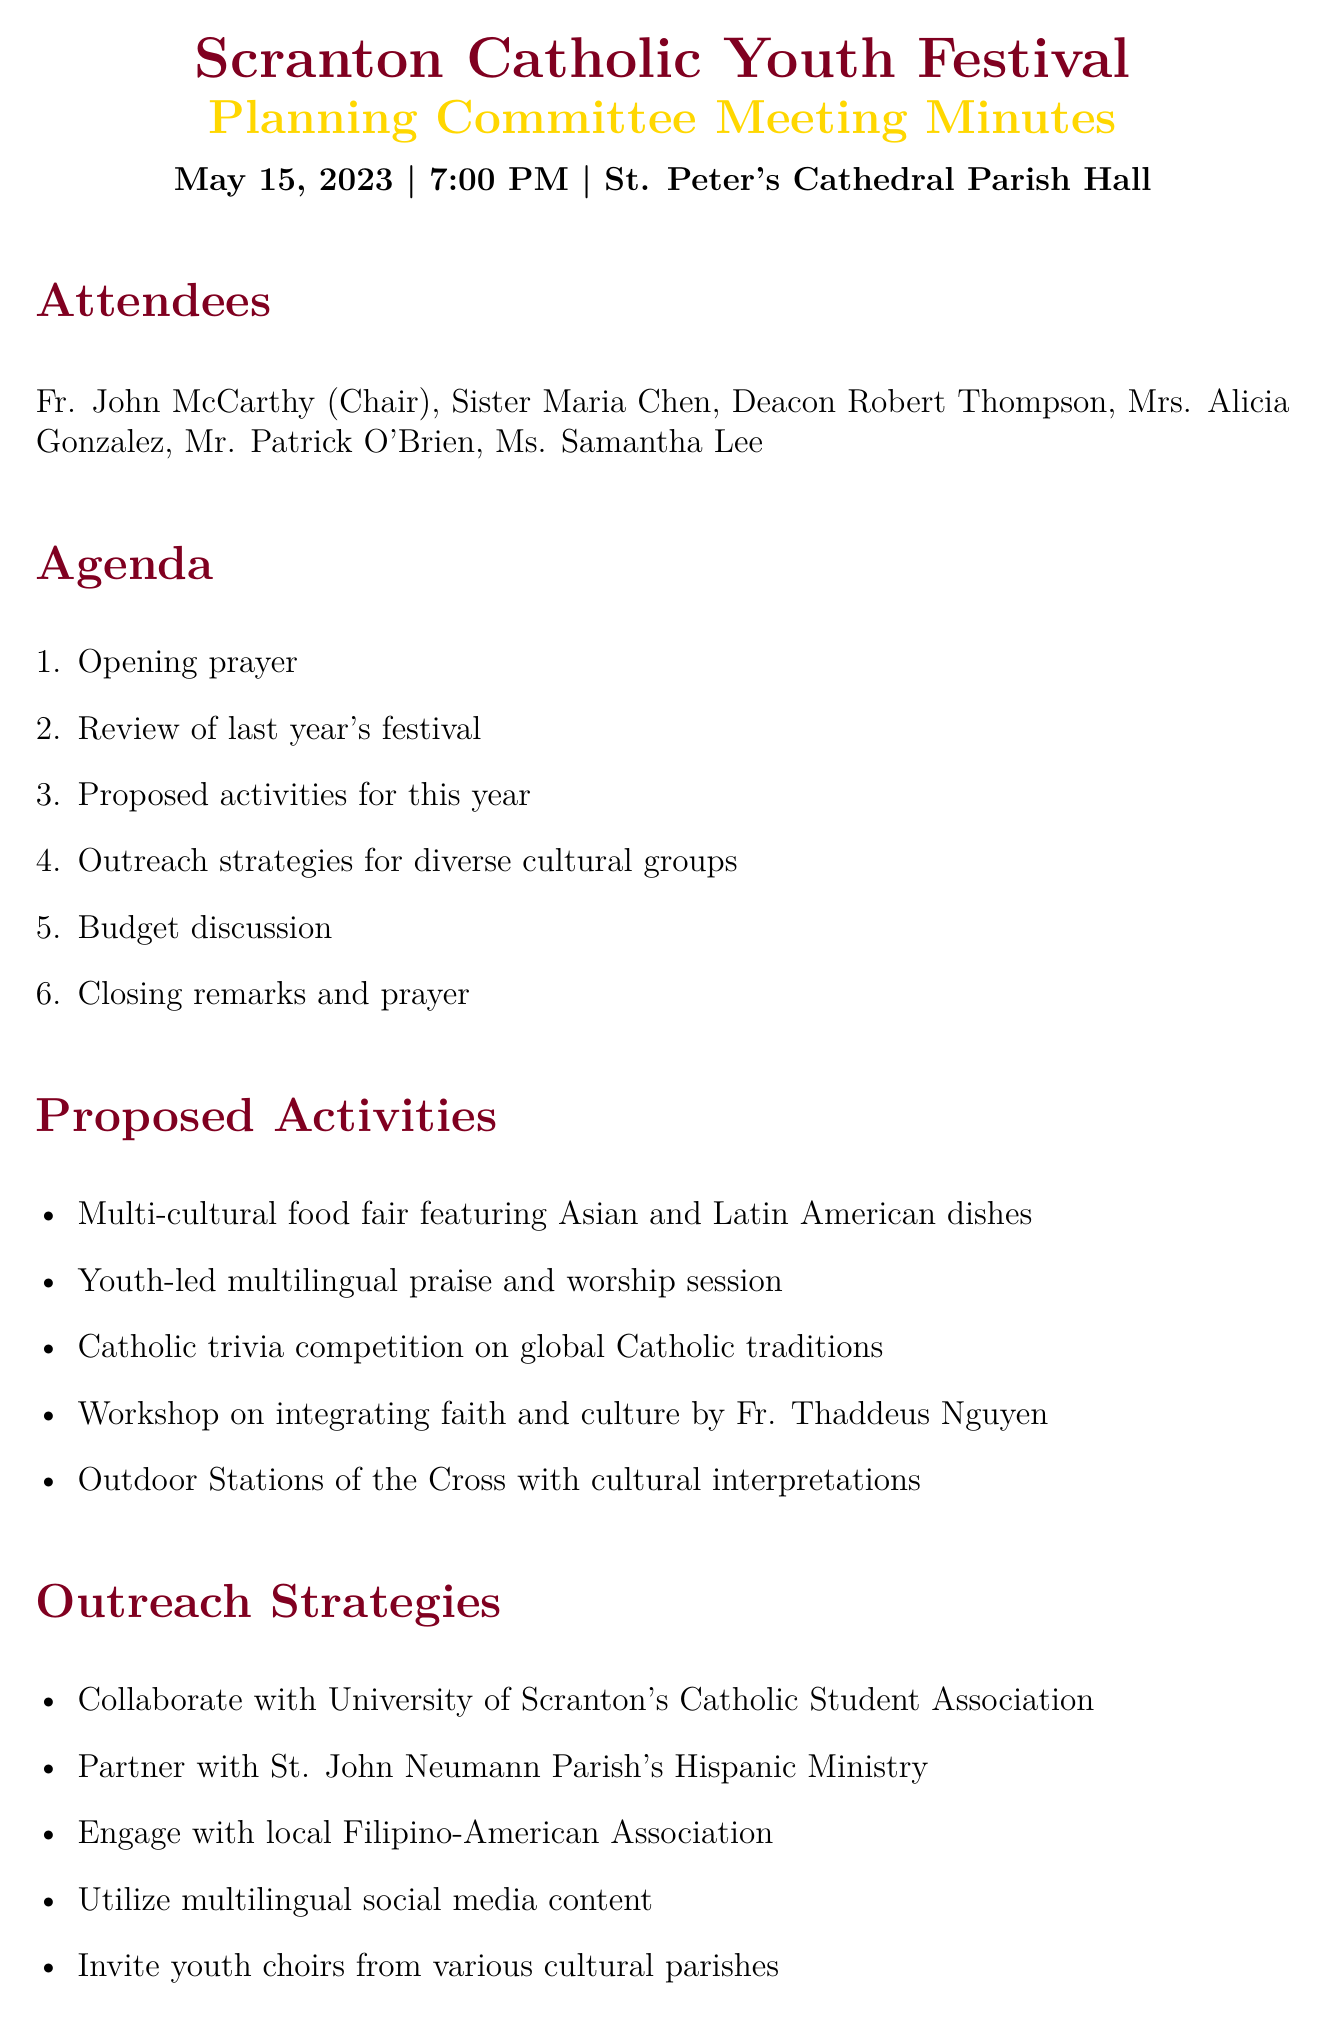what is the date of the meeting? The date of the meeting is specifically mentioned in the document as May 15, 2023.
Answer: May 15, 2023 who is the chair of the meeting? The document lists Fr. John McCarthy as the chair of the meeting.
Answer: Fr. John McCarthy how much is the estimated total cost for the festival? The document states the estimated total cost is $15,000.
Answer: $15,000 what type of food fair is proposed for the festival? The meeting minutes specify a multi-cultural food fair featuring dishes from various Asian and Latin American countries.
Answer: multi-cultural food fair which parish's Hispanic Ministry will be partnered with for outreach? The outreach strategy mentions partnering with St. John Neumann Parish's Hispanic Ministry for targeted outreach.
Answer: St. John Neumann Parish how many major expenses are outlined in the budget? The document lists four major expenses in the budget section.
Answer: four what is one action item assigned to Mrs. Gonzalez? The action items state that Mrs. Gonzalez will coordinate with the University of Scranton for student involvement.
Answer: coordinate with University of Scranton what is one proposed activity that focuses on youth? The document mentions a youth-led multilingual praise and worship session as a proposed activity for the festival.
Answer: youth-led multilingual praise and worship session how will social media be utilized for the festival? The outreach strategies include utilizing social media platforms with multilingual content to attract diverse participants.
Answer: multilingual content on social media 